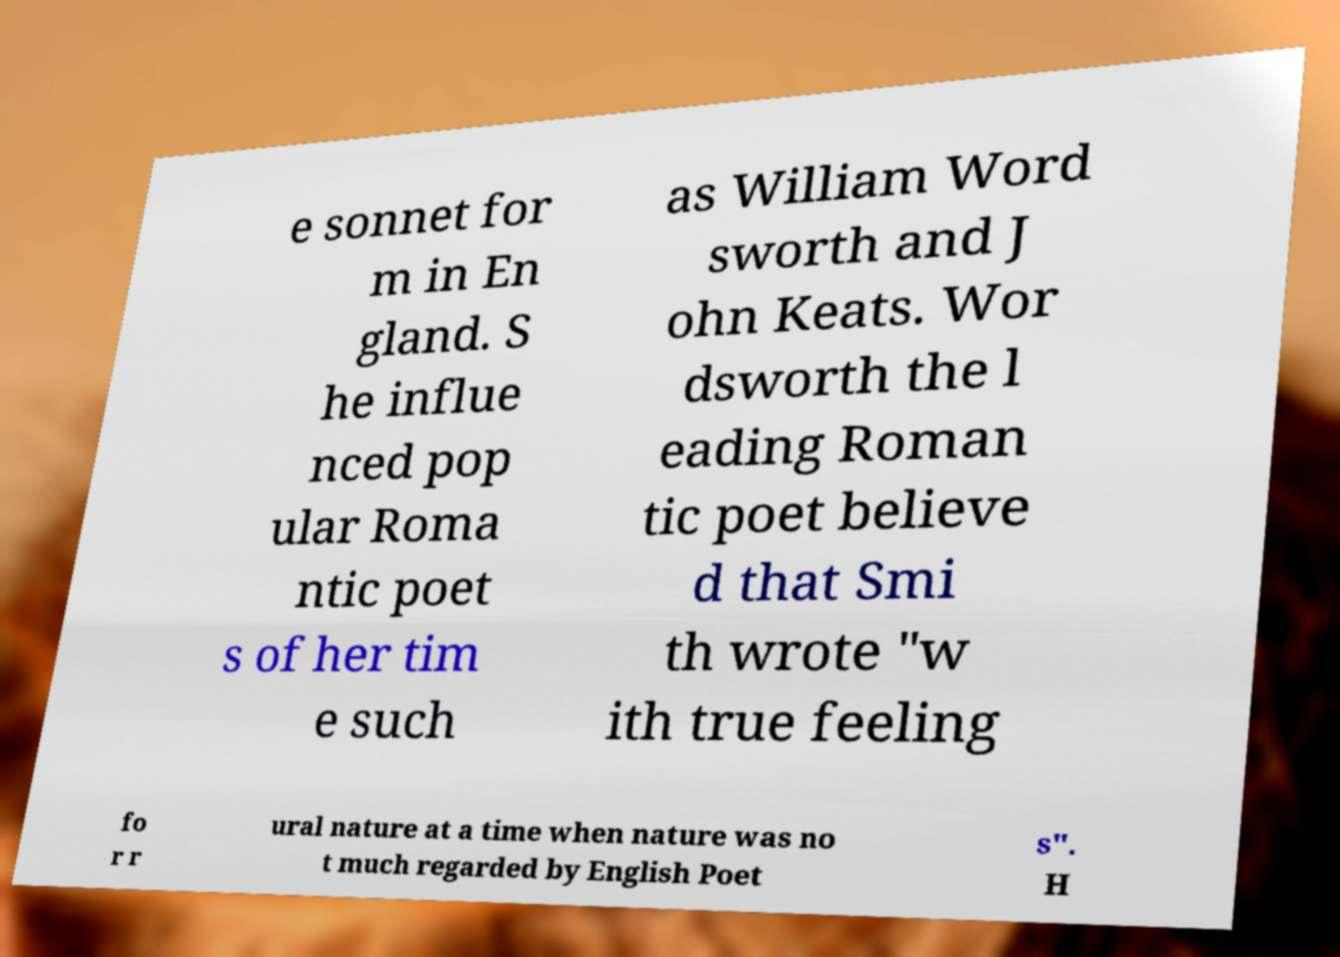What messages or text are displayed in this image? I need them in a readable, typed format. e sonnet for m in En gland. S he influe nced pop ular Roma ntic poet s of her tim e such as William Word sworth and J ohn Keats. Wor dsworth the l eading Roman tic poet believe d that Smi th wrote "w ith true feeling fo r r ural nature at a time when nature was no t much regarded by English Poet s". H 